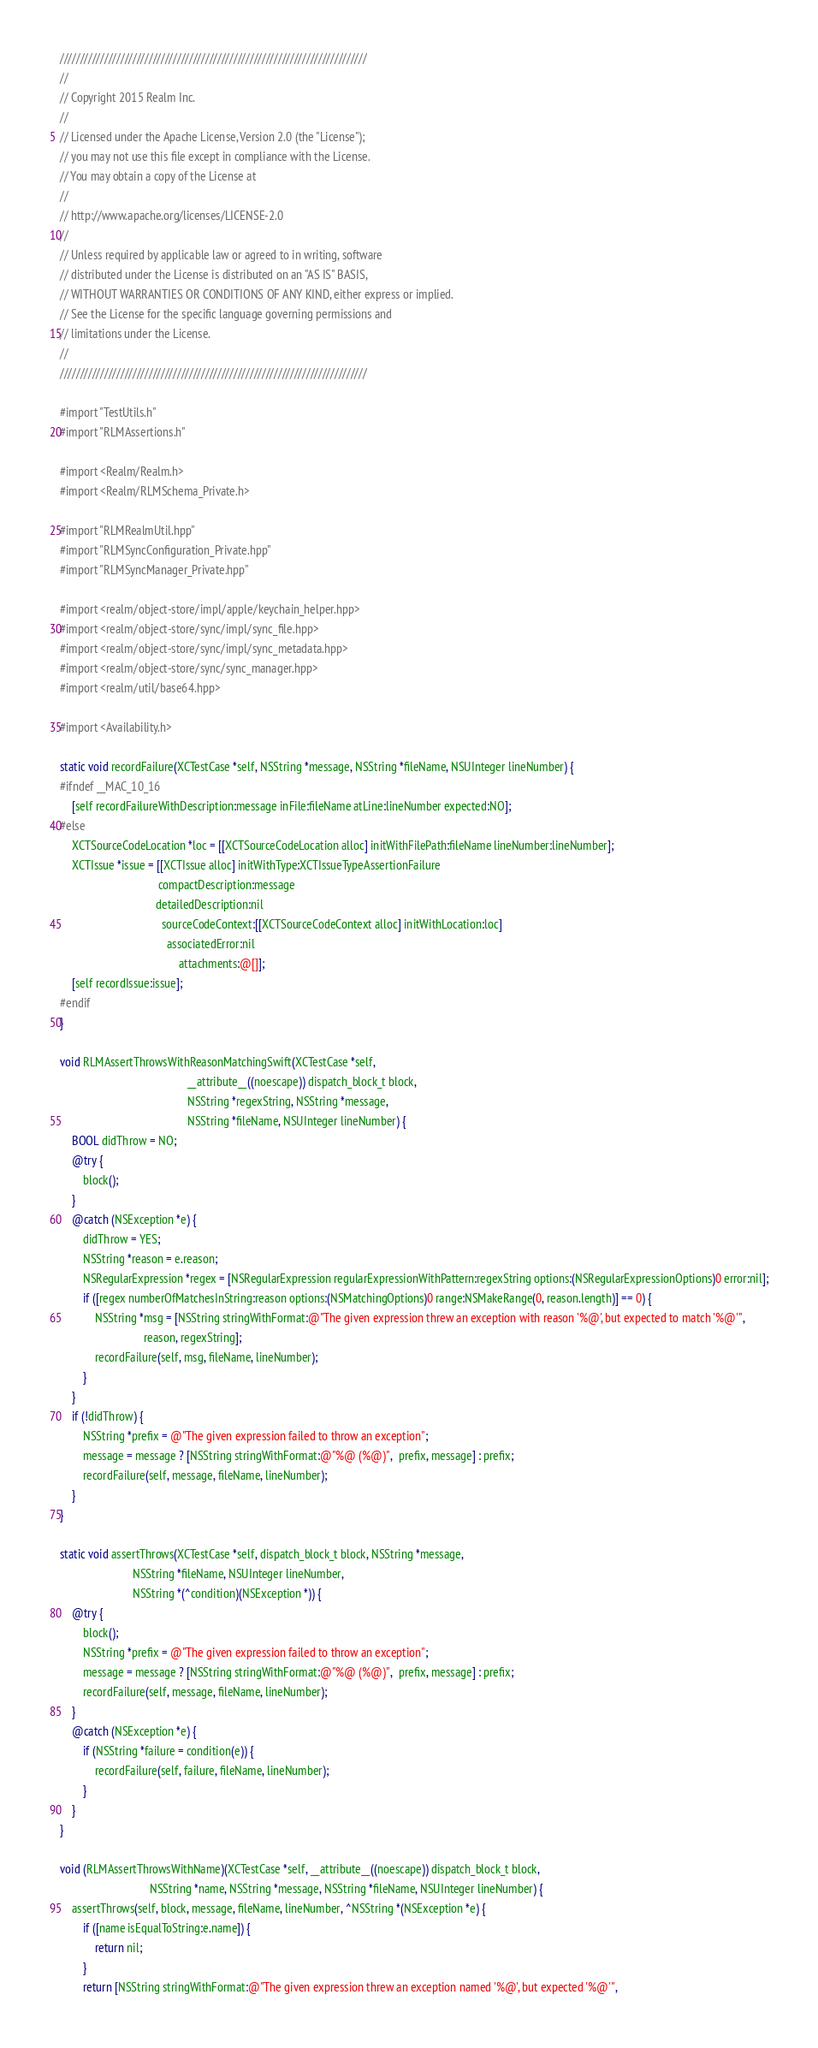Convert code to text. <code><loc_0><loc_0><loc_500><loc_500><_ObjectiveC_>////////////////////////////////////////////////////////////////////////////
//
// Copyright 2015 Realm Inc.
//
// Licensed under the Apache License, Version 2.0 (the "License");
// you may not use this file except in compliance with the License.
// You may obtain a copy of the License at
//
// http://www.apache.org/licenses/LICENSE-2.0
//
// Unless required by applicable law or agreed to in writing, software
// distributed under the License is distributed on an "AS IS" BASIS,
// WITHOUT WARRANTIES OR CONDITIONS OF ANY KIND, either express or implied.
// See the License for the specific language governing permissions and
// limitations under the License.
//
////////////////////////////////////////////////////////////////////////////

#import "TestUtils.h"
#import "RLMAssertions.h"

#import <Realm/Realm.h>
#import <Realm/RLMSchema_Private.h>

#import "RLMRealmUtil.hpp"
#import "RLMSyncConfiguration_Private.hpp"
#import "RLMSyncManager_Private.hpp"

#import <realm/object-store/impl/apple/keychain_helper.hpp>
#import <realm/object-store/sync/impl/sync_file.hpp>
#import <realm/object-store/sync/impl/sync_metadata.hpp>
#import <realm/object-store/sync/sync_manager.hpp>
#import <realm/util/base64.hpp>

#import <Availability.h>

static void recordFailure(XCTestCase *self, NSString *message, NSString *fileName, NSUInteger lineNumber) {
#ifndef __MAC_10_16
    [self recordFailureWithDescription:message inFile:fileName atLine:lineNumber expected:NO];
#else
    XCTSourceCodeLocation *loc = [[XCTSourceCodeLocation alloc] initWithFilePath:fileName lineNumber:lineNumber];
    XCTIssue *issue = [[XCTIssue alloc] initWithType:XCTIssueTypeAssertionFailure
                                  compactDescription:message
                                 detailedDescription:nil
                                   sourceCodeContext:[[XCTSourceCodeContext alloc] initWithLocation:loc]
                                     associatedError:nil
                                         attachments:@[]];
    [self recordIssue:issue];
#endif
}

void RLMAssertThrowsWithReasonMatchingSwift(XCTestCase *self,
                                            __attribute__((noescape)) dispatch_block_t block,
                                            NSString *regexString, NSString *message,
                                            NSString *fileName, NSUInteger lineNumber) {
    BOOL didThrow = NO;
    @try {
        block();
    }
    @catch (NSException *e) {
        didThrow = YES;
        NSString *reason = e.reason;
        NSRegularExpression *regex = [NSRegularExpression regularExpressionWithPattern:regexString options:(NSRegularExpressionOptions)0 error:nil];
        if ([regex numberOfMatchesInString:reason options:(NSMatchingOptions)0 range:NSMakeRange(0, reason.length)] == 0) {
            NSString *msg = [NSString stringWithFormat:@"The given expression threw an exception with reason '%@', but expected to match '%@'",
                             reason, regexString];
            recordFailure(self, msg, fileName, lineNumber);
        }
    }
    if (!didThrow) {
        NSString *prefix = @"The given expression failed to throw an exception";
        message = message ? [NSString stringWithFormat:@"%@ (%@)",  prefix, message] : prefix;
        recordFailure(self, message, fileName, lineNumber);
    }
}

static void assertThrows(XCTestCase *self, dispatch_block_t block, NSString *message,
                         NSString *fileName, NSUInteger lineNumber,
                         NSString *(^condition)(NSException *)) {
    @try {
        block();
        NSString *prefix = @"The given expression failed to throw an exception";
        message = message ? [NSString stringWithFormat:@"%@ (%@)",  prefix, message] : prefix;
        recordFailure(self, message, fileName, lineNumber);
    }
    @catch (NSException *e) {
        if (NSString *failure = condition(e)) {
            recordFailure(self, failure, fileName, lineNumber);
        }
    }
}

void (RLMAssertThrowsWithName)(XCTestCase *self, __attribute__((noescape)) dispatch_block_t block,
                               NSString *name, NSString *message, NSString *fileName, NSUInteger lineNumber) {
    assertThrows(self, block, message, fileName, lineNumber, ^NSString *(NSException *e) {
        if ([name isEqualToString:e.name]) {
            return nil;
        }
        return [NSString stringWithFormat:@"The given expression threw an exception named '%@', but expected '%@'",</code> 